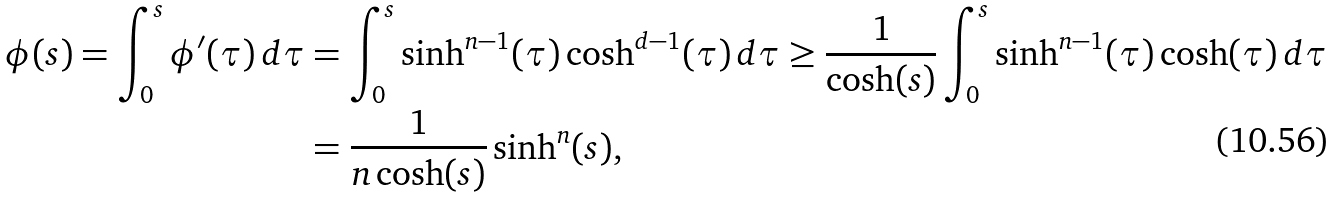<formula> <loc_0><loc_0><loc_500><loc_500>\phi ( s ) = \int _ { 0 } ^ { s } \phi ^ { \prime } ( \tau ) \, d \tau & = \int _ { 0 } ^ { s } \sinh ^ { n - 1 } ( \tau ) \cosh ^ { d - 1 } ( \tau ) \, d \tau \geq \frac { 1 } { \cosh ( s ) } \int _ { 0 } ^ { s } \sinh ^ { n - 1 } ( \tau ) \cosh ( \tau ) \, d \tau \\ & = \frac { 1 } { n \cosh ( s ) } \sinh ^ { n } ( s ) ,</formula> 